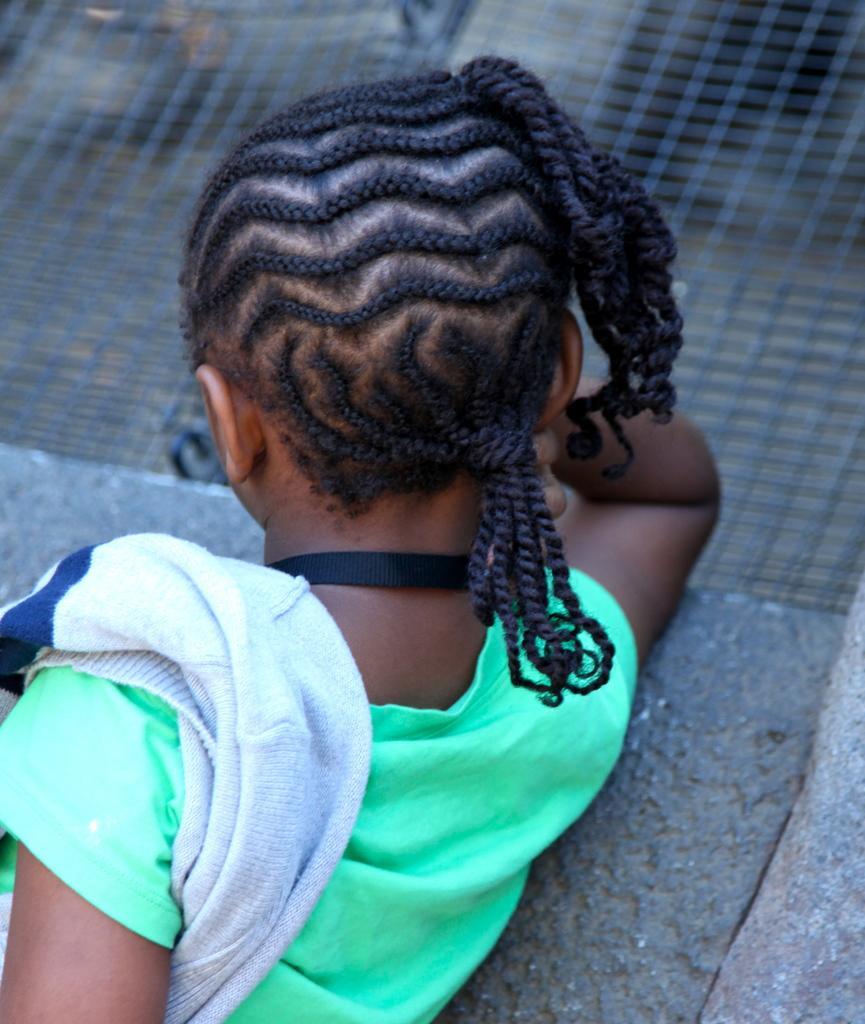Describe this image in one or two sentences. Here we can see a person. This person wore a green t-shirt. Background it is blurry and we can see a mesh.  